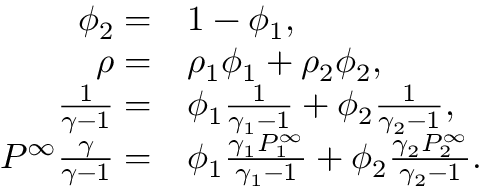Convert formula to latex. <formula><loc_0><loc_0><loc_500><loc_500>\begin{array} { r l } { \phi _ { 2 } = } & { 1 - \phi _ { 1 } , } \\ { \rho = } & { \rho _ { 1 } \phi _ { 1 } + \rho _ { 2 } \phi _ { 2 } , } \\ { \frac { 1 } { \gamma - 1 } = } & { \phi _ { 1 } \frac { 1 } { \gamma _ { 1 } - 1 } + \phi _ { 2 } \frac { 1 } { \gamma _ { 2 } - 1 } , } \\ { P ^ { \infty } \frac { \gamma } { \gamma - 1 } = } & { \phi _ { 1 } \frac { \gamma _ { 1 } P _ { 1 } ^ { \infty } } { \gamma _ { 1 } - 1 } + \phi _ { 2 } \frac { \gamma _ { 2 } P _ { 2 } ^ { \infty } } { \gamma _ { 2 } - 1 } . } \end{array}</formula> 